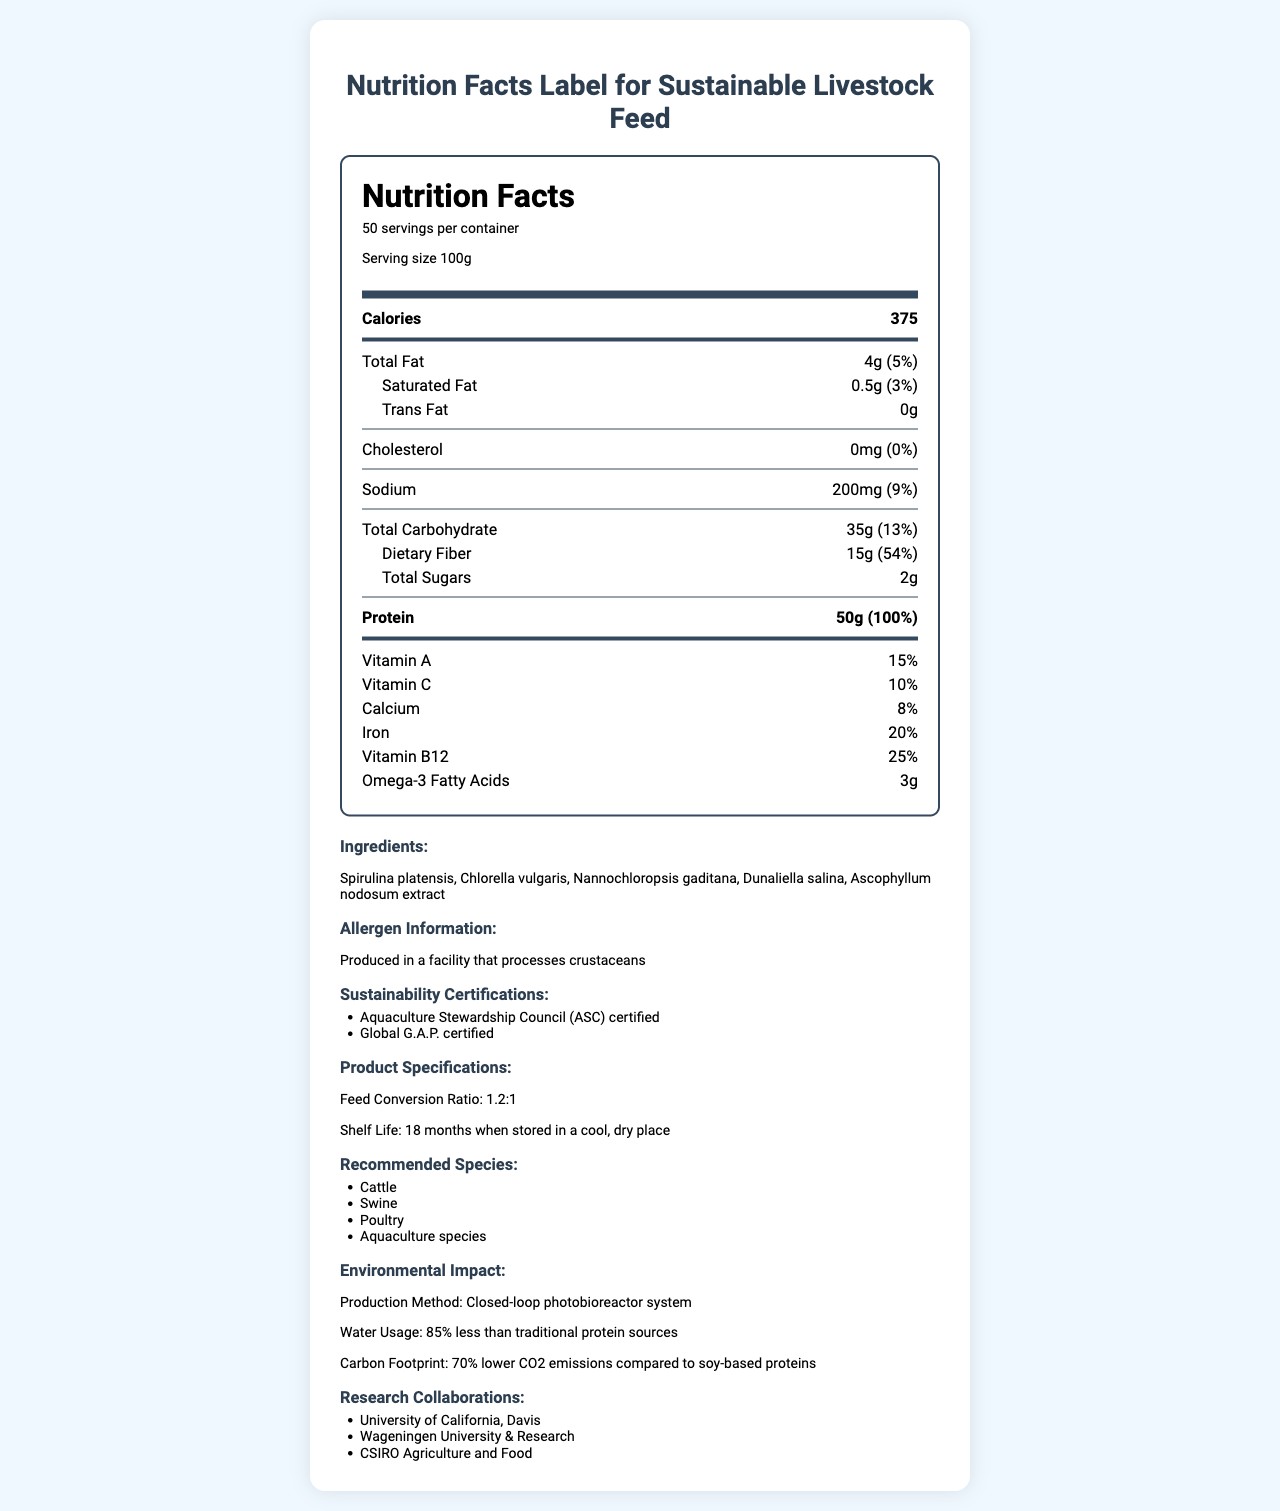what is the product name? The product name is clearly labeled at the top of the document.
Answer: AlgaePro Livestock Feed how many servings per container are there? The document states that there are 50 servings per container.
Answer: 50 what is the serving size for this product? The serving size is mentioned in the serving information section.
Answer: 100g how much protein is in one serving? The amount of protein per serving is listed as 50g in the nutrition label.
Answer: 50g how much dietary fiber does this product contain per serving? The document specifies that each serving contains 15g of dietary fiber.
Answer: 15g what is the feed conversion ratio? The feed conversion ratio is listed in the product specifications section.
Answer: 1.2:1 how long is the shelf life of this product? A. 12 months B. 18 months C. 24 months The shelf life is stated as 18 months when stored in a cool, dry place.
Answer: B which of the following certifications does this product have? I. USDA Organic II. Aquaculture Stewardship Council (ASC) III. Global G.A.P. A. I only B. II only C. II and III The document lists the product as being ASC and Global G.A.P. certified.
Answer: C does the product contain any cholesterol? The nutrition label shows 0mg of cholesterol.
Answer: No is this product suitable for poultry? Poultry is listed as one of the recommended species for this feed.
Answer: Yes what is the primary environmental benefit mentioned for the production method? The environmental impact section states the significant water usage reduction in the production method.
Answer: Uses 85% less water than traditional protein sources why is this product more sustainable compared to soy-based proteins? The document states that it uses 85% less water and has 70% lower CO2 emissions compared to soy-based proteins.
Answer: Lower water usage and carbon footprint can this document tell us the market price of "AlgaePro Livestock Feed"? The document does not provide any information about the market price of the product.
Answer: Cannot be determined summarize the main idea of the document The summary captures the key aspects: nutritional content, environmental benefits, recommended species, sustainability certifications, and other relevant product details.
Answer: "AlgaePro Livestock Feed" is a sustainable algae-based protein powder designed for livestock, offering high nutritional value with a significant protein content and essential vitamins. The product stands out due to its efficient feed conversion ratio, extended shelf life, and environmental sustainability, consuming less water and producing lower carbon emissions. It is certified by ASC and Global G.A.P. and recommended for various species such as cattle, swine, poultry, and aquaculture. 